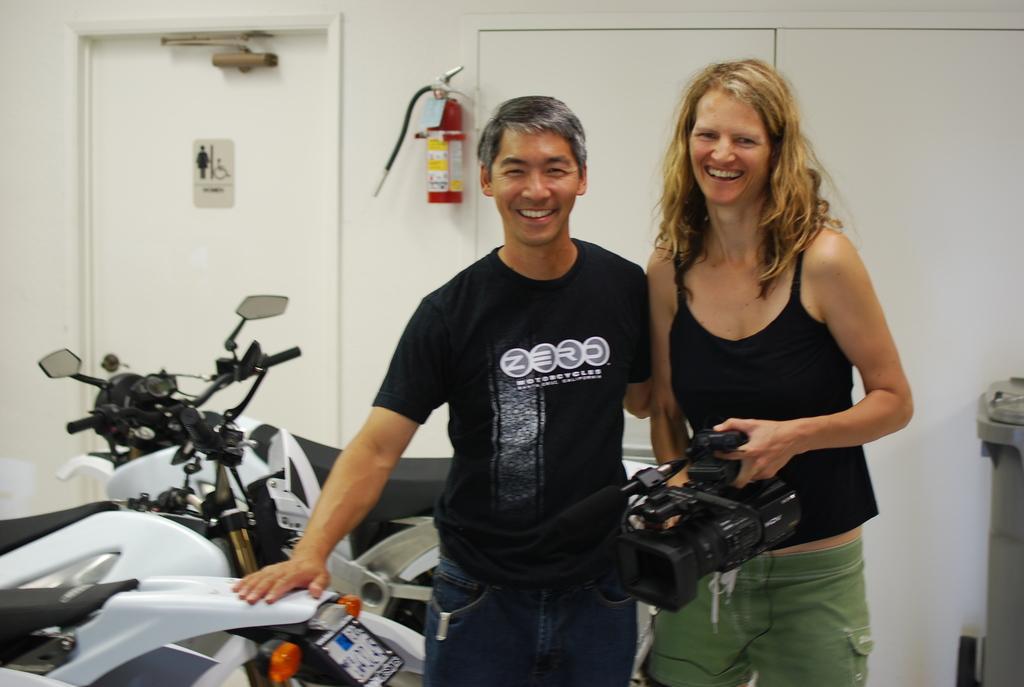In one or two sentences, can you explain what this image depicts? In this picture, we see three white bikes. In the middle of the picture, we see man wearing black t-shirt and blue jeans is laughing and he is putting one of his hand on the bike. Beside him, we see woman in black t-shirt and green jeans is holding video camera in her hand and she is smiling. Behind them, we see a door which is white in color and beside that we see fire extinguisher. 